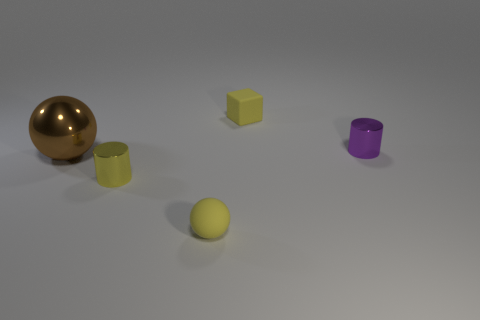Add 4 yellow rubber balls. How many objects exist? 9 Subtract all balls. How many objects are left? 3 Add 4 purple metal things. How many purple metal things are left? 5 Add 3 tiny yellow cubes. How many tiny yellow cubes exist? 4 Subtract 1 purple cylinders. How many objects are left? 4 Subtract all green objects. Subtract all small purple things. How many objects are left? 4 